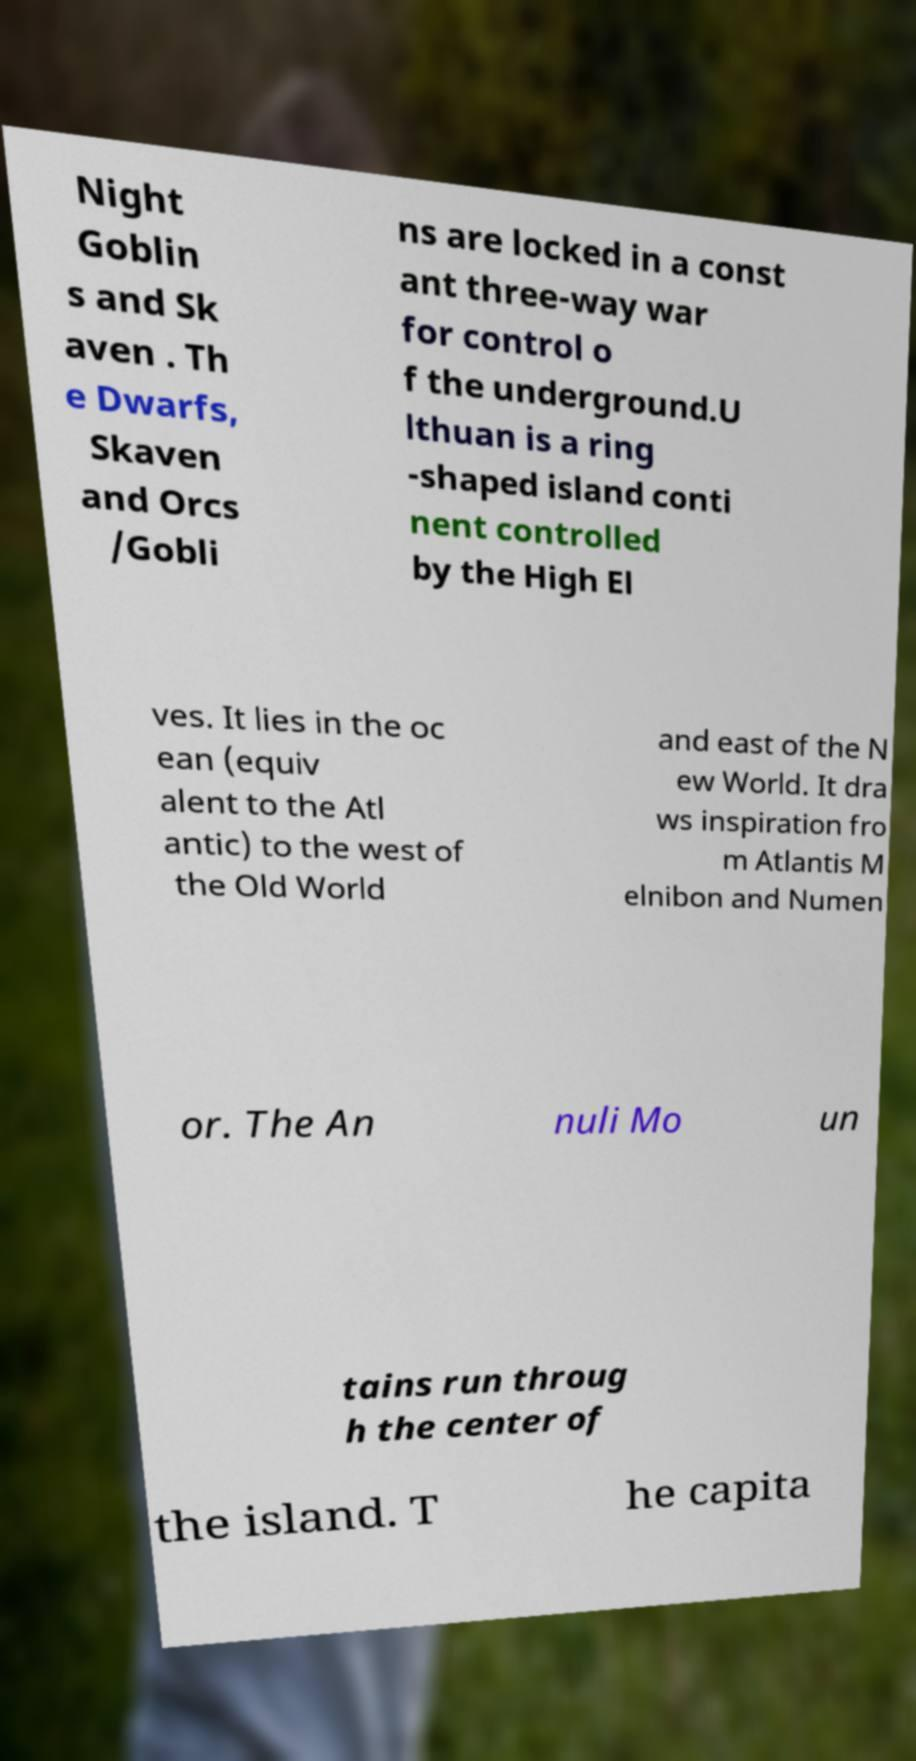What messages or text are displayed in this image? I need them in a readable, typed format. Night Goblin s and Sk aven . Th e Dwarfs, Skaven and Orcs /Gobli ns are locked in a const ant three-way war for control o f the underground.U lthuan is a ring -shaped island conti nent controlled by the High El ves. It lies in the oc ean (equiv alent to the Atl antic) to the west of the Old World and east of the N ew World. It dra ws inspiration fro m Atlantis M elnibon and Numen or. The An nuli Mo un tains run throug h the center of the island. T he capita 